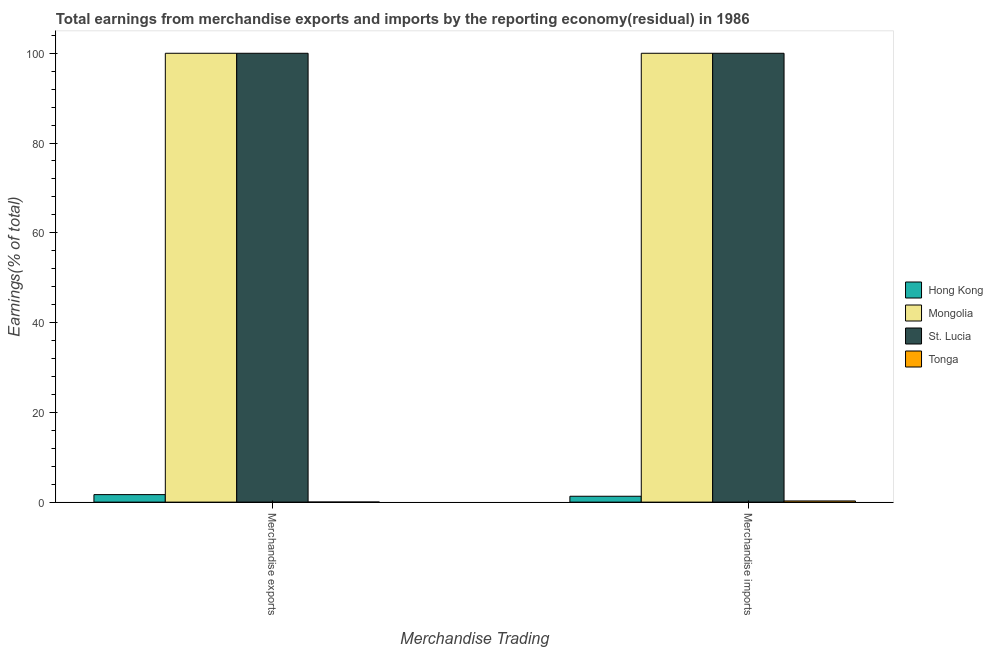How many groups of bars are there?
Ensure brevity in your answer.  2. Are the number of bars on each tick of the X-axis equal?
Your answer should be very brief. Yes. How many bars are there on the 1st tick from the right?
Your response must be concise. 4. What is the earnings from merchandise imports in Tonga?
Ensure brevity in your answer.  0.26. Across all countries, what is the maximum earnings from merchandise exports?
Your response must be concise. 100. Across all countries, what is the minimum earnings from merchandise imports?
Provide a short and direct response. 0.26. In which country was the earnings from merchandise imports maximum?
Offer a very short reply. Mongolia. In which country was the earnings from merchandise imports minimum?
Offer a terse response. Tonga. What is the total earnings from merchandise imports in the graph?
Offer a terse response. 201.57. What is the difference between the earnings from merchandise exports in St. Lucia and that in Hong Kong?
Provide a short and direct response. 98.33. What is the difference between the earnings from merchandise exports in Tonga and the earnings from merchandise imports in Hong Kong?
Your response must be concise. -1.29. What is the average earnings from merchandise exports per country?
Offer a very short reply. 50.42. What is the difference between the earnings from merchandise exports and earnings from merchandise imports in Mongolia?
Your answer should be very brief. 0. What is the ratio of the earnings from merchandise exports in Hong Kong to that in St. Lucia?
Keep it short and to the point. 0.02. In how many countries, is the earnings from merchandise exports greater than the average earnings from merchandise exports taken over all countries?
Provide a succinct answer. 2. What does the 3rd bar from the left in Merchandise imports represents?
Provide a short and direct response. St. Lucia. What does the 3rd bar from the right in Merchandise imports represents?
Keep it short and to the point. Mongolia. Are all the bars in the graph horizontal?
Provide a succinct answer. No. How many countries are there in the graph?
Give a very brief answer. 4. What is the difference between two consecutive major ticks on the Y-axis?
Your response must be concise. 20. Does the graph contain any zero values?
Give a very brief answer. No. Where does the legend appear in the graph?
Your answer should be compact. Center right. What is the title of the graph?
Make the answer very short. Total earnings from merchandise exports and imports by the reporting economy(residual) in 1986. What is the label or title of the X-axis?
Your answer should be very brief. Merchandise Trading. What is the label or title of the Y-axis?
Offer a very short reply. Earnings(% of total). What is the Earnings(% of total) of Hong Kong in Merchandise exports?
Your response must be concise. 1.67. What is the Earnings(% of total) of Tonga in Merchandise exports?
Offer a very short reply. 0.02. What is the Earnings(% of total) in Hong Kong in Merchandise imports?
Provide a succinct answer. 1.31. What is the Earnings(% of total) of Mongolia in Merchandise imports?
Ensure brevity in your answer.  100. What is the Earnings(% of total) in St. Lucia in Merchandise imports?
Your response must be concise. 100. What is the Earnings(% of total) of Tonga in Merchandise imports?
Keep it short and to the point. 0.26. Across all Merchandise Trading, what is the maximum Earnings(% of total) in Hong Kong?
Your answer should be very brief. 1.67. Across all Merchandise Trading, what is the maximum Earnings(% of total) in St. Lucia?
Provide a short and direct response. 100. Across all Merchandise Trading, what is the maximum Earnings(% of total) of Tonga?
Offer a terse response. 0.26. Across all Merchandise Trading, what is the minimum Earnings(% of total) of Hong Kong?
Offer a terse response. 1.31. Across all Merchandise Trading, what is the minimum Earnings(% of total) in Tonga?
Offer a very short reply. 0.02. What is the total Earnings(% of total) in Hong Kong in the graph?
Give a very brief answer. 2.98. What is the total Earnings(% of total) of Mongolia in the graph?
Provide a short and direct response. 200. What is the total Earnings(% of total) of Tonga in the graph?
Make the answer very short. 0.28. What is the difference between the Earnings(% of total) of Hong Kong in Merchandise exports and that in Merchandise imports?
Your answer should be very brief. 0.36. What is the difference between the Earnings(% of total) in Tonga in Merchandise exports and that in Merchandise imports?
Offer a terse response. -0.25. What is the difference between the Earnings(% of total) in Hong Kong in Merchandise exports and the Earnings(% of total) in Mongolia in Merchandise imports?
Your answer should be very brief. -98.33. What is the difference between the Earnings(% of total) of Hong Kong in Merchandise exports and the Earnings(% of total) of St. Lucia in Merchandise imports?
Your answer should be very brief. -98.33. What is the difference between the Earnings(% of total) of Hong Kong in Merchandise exports and the Earnings(% of total) of Tonga in Merchandise imports?
Provide a succinct answer. 1.41. What is the difference between the Earnings(% of total) of Mongolia in Merchandise exports and the Earnings(% of total) of St. Lucia in Merchandise imports?
Ensure brevity in your answer.  0. What is the difference between the Earnings(% of total) of Mongolia in Merchandise exports and the Earnings(% of total) of Tonga in Merchandise imports?
Your response must be concise. 99.74. What is the difference between the Earnings(% of total) in St. Lucia in Merchandise exports and the Earnings(% of total) in Tonga in Merchandise imports?
Your answer should be compact. 99.74. What is the average Earnings(% of total) of Hong Kong per Merchandise Trading?
Your answer should be compact. 1.49. What is the average Earnings(% of total) of Mongolia per Merchandise Trading?
Provide a succinct answer. 100. What is the average Earnings(% of total) of St. Lucia per Merchandise Trading?
Provide a short and direct response. 100. What is the average Earnings(% of total) in Tonga per Merchandise Trading?
Ensure brevity in your answer.  0.14. What is the difference between the Earnings(% of total) in Hong Kong and Earnings(% of total) in Mongolia in Merchandise exports?
Offer a very short reply. -98.33. What is the difference between the Earnings(% of total) of Hong Kong and Earnings(% of total) of St. Lucia in Merchandise exports?
Give a very brief answer. -98.33. What is the difference between the Earnings(% of total) of Hong Kong and Earnings(% of total) of Tonga in Merchandise exports?
Provide a succinct answer. 1.65. What is the difference between the Earnings(% of total) of Mongolia and Earnings(% of total) of Tonga in Merchandise exports?
Your answer should be compact. 99.98. What is the difference between the Earnings(% of total) of St. Lucia and Earnings(% of total) of Tonga in Merchandise exports?
Give a very brief answer. 99.98. What is the difference between the Earnings(% of total) of Hong Kong and Earnings(% of total) of Mongolia in Merchandise imports?
Keep it short and to the point. -98.69. What is the difference between the Earnings(% of total) of Hong Kong and Earnings(% of total) of St. Lucia in Merchandise imports?
Give a very brief answer. -98.69. What is the difference between the Earnings(% of total) in Hong Kong and Earnings(% of total) in Tonga in Merchandise imports?
Your answer should be compact. 1.04. What is the difference between the Earnings(% of total) in Mongolia and Earnings(% of total) in Tonga in Merchandise imports?
Ensure brevity in your answer.  99.74. What is the difference between the Earnings(% of total) of St. Lucia and Earnings(% of total) of Tonga in Merchandise imports?
Offer a very short reply. 99.74. What is the ratio of the Earnings(% of total) of Hong Kong in Merchandise exports to that in Merchandise imports?
Your answer should be very brief. 1.28. What is the ratio of the Earnings(% of total) in Tonga in Merchandise exports to that in Merchandise imports?
Your response must be concise. 0.07. What is the difference between the highest and the second highest Earnings(% of total) of Hong Kong?
Your response must be concise. 0.36. What is the difference between the highest and the second highest Earnings(% of total) in Mongolia?
Keep it short and to the point. 0. What is the difference between the highest and the second highest Earnings(% of total) in Tonga?
Give a very brief answer. 0.25. What is the difference between the highest and the lowest Earnings(% of total) of Hong Kong?
Offer a very short reply. 0.36. What is the difference between the highest and the lowest Earnings(% of total) in Mongolia?
Keep it short and to the point. 0. What is the difference between the highest and the lowest Earnings(% of total) in St. Lucia?
Your answer should be very brief. 0. What is the difference between the highest and the lowest Earnings(% of total) in Tonga?
Your response must be concise. 0.25. 